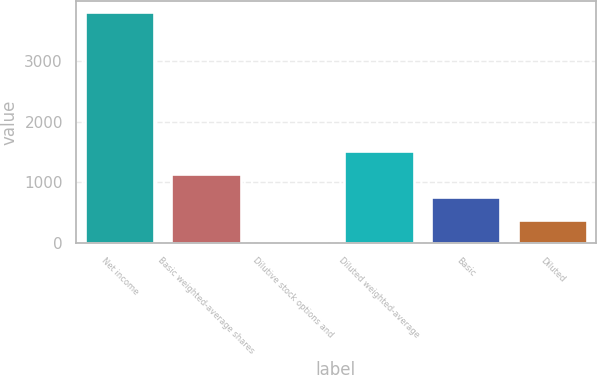<chart> <loc_0><loc_0><loc_500><loc_500><bar_chart><fcel>Net income<fcel>Basic weighted-average shares<fcel>Dilutive stock options and<fcel>Diluted weighted-average<fcel>Basic<fcel>Diluted<nl><fcel>3808<fcel>1144.5<fcel>3<fcel>1525<fcel>764<fcel>383.5<nl></chart> 